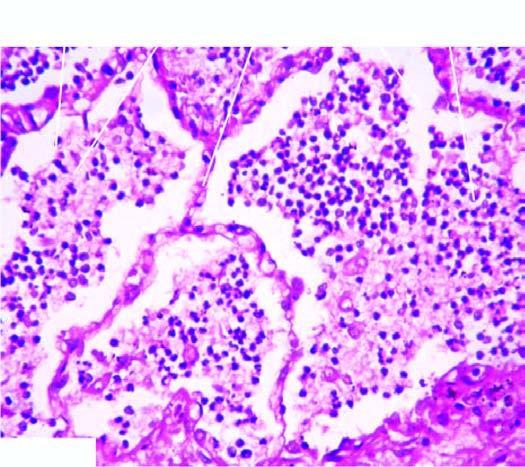does the sectioned surface of the lung show grey-brown, firm area of consolidation affecting a lobe?
Answer the question using a single word or phrase. Yes 